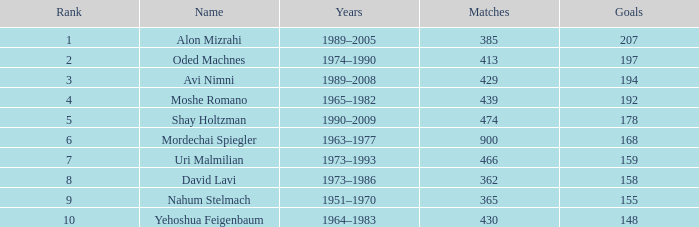What is the position of the player with 158 goals in over 362 matches? 0.0. 